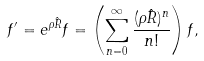Convert formula to latex. <formula><loc_0><loc_0><loc_500><loc_500>f ^ { \prime } = e ^ { \rho \hat { R } } f = \left ( \sum _ { n = 0 } ^ { \infty } \frac { ( \rho \hat { R } ) ^ { n } } { n ! } \right ) f ,</formula> 